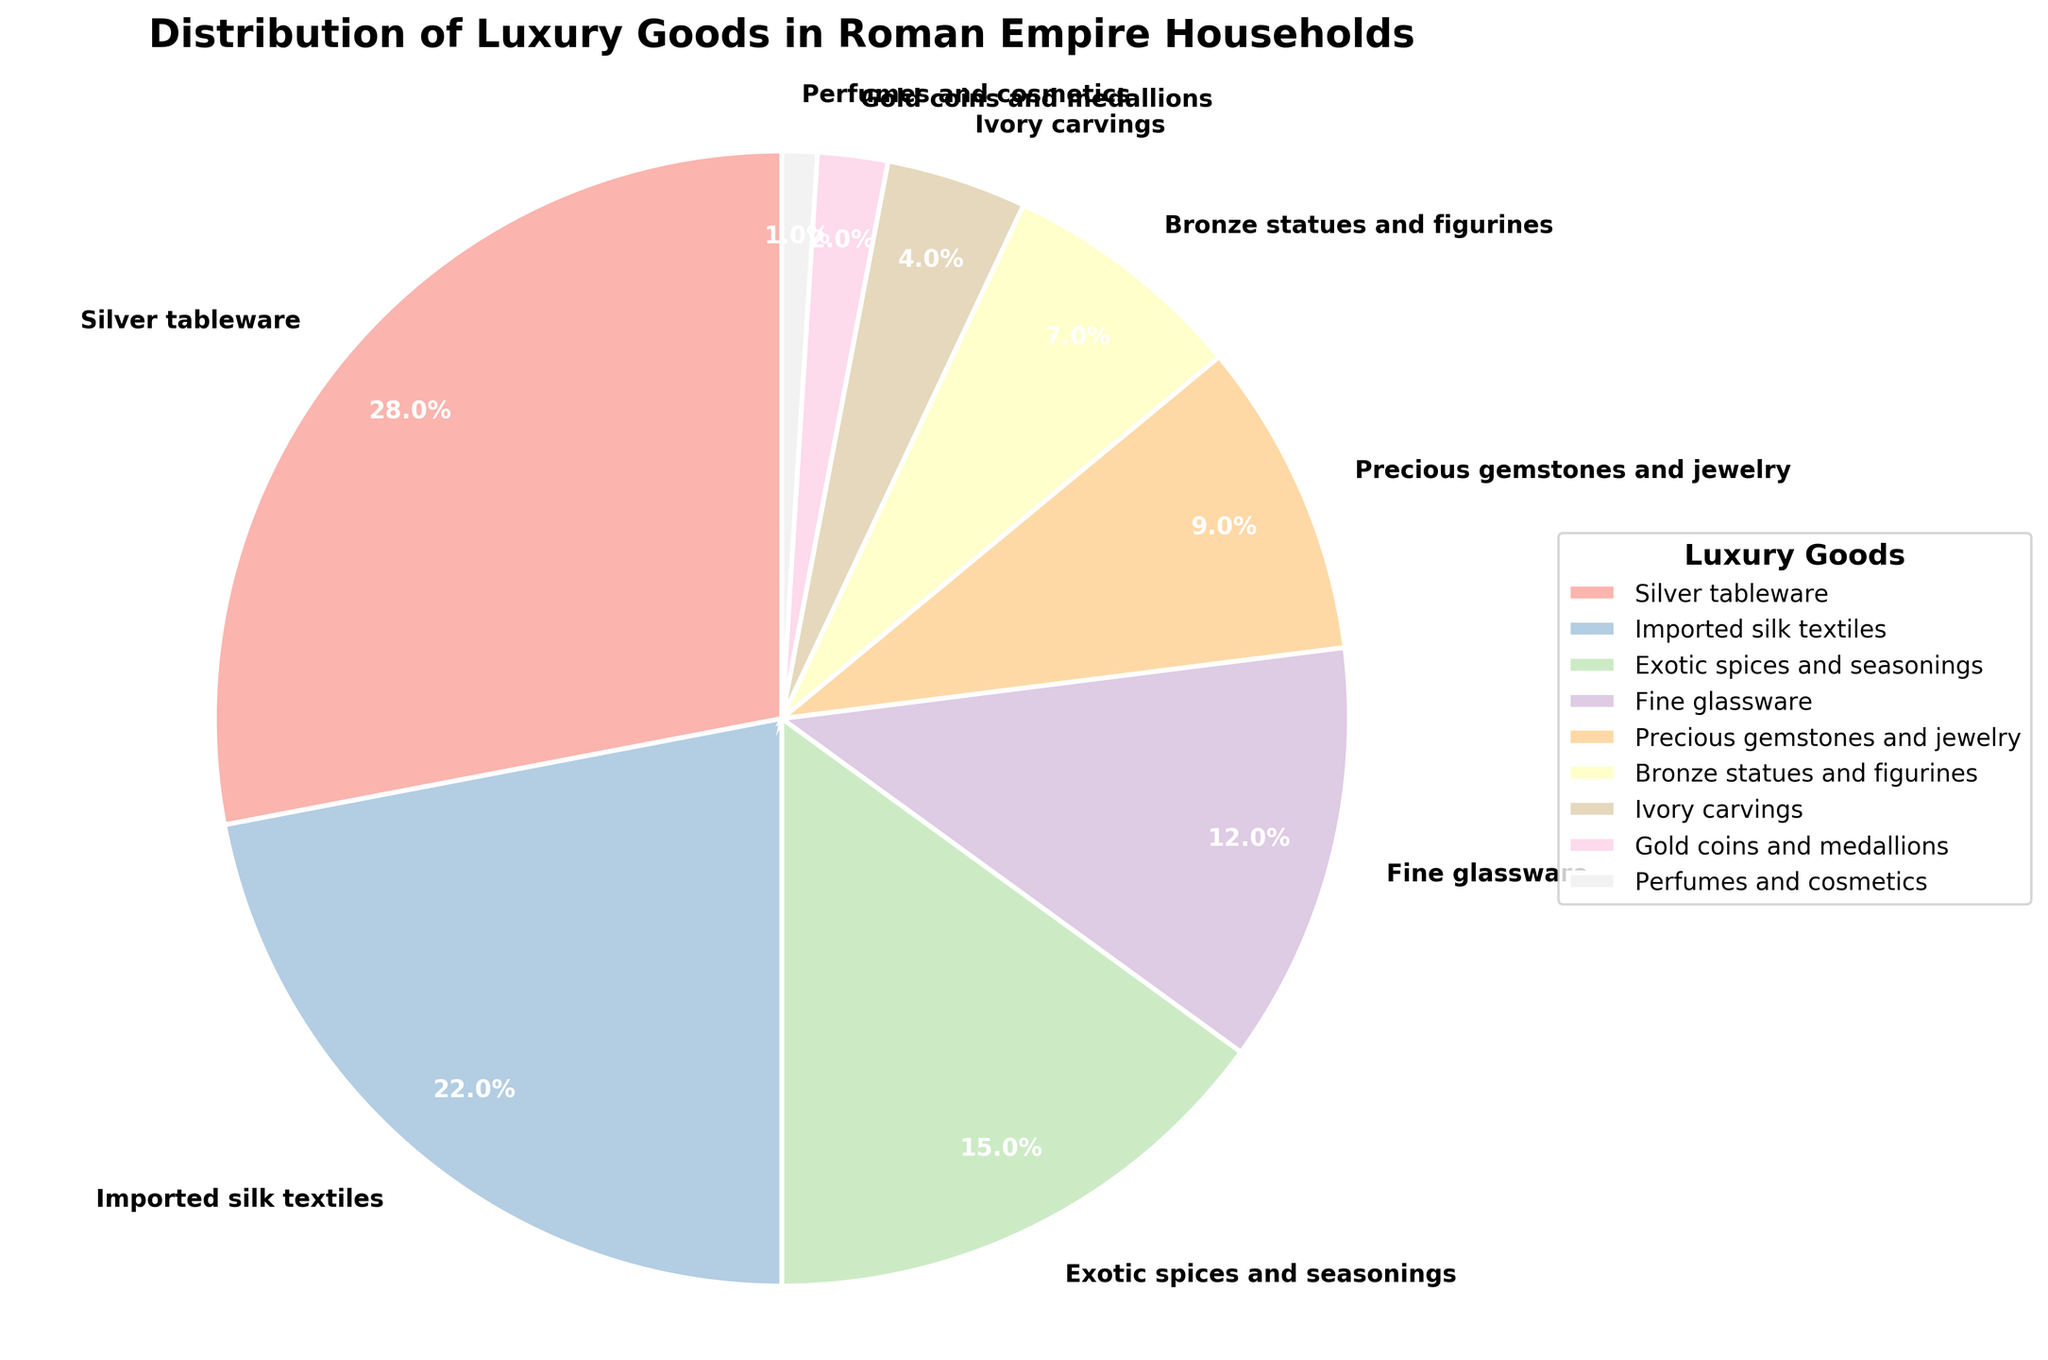Which category accounts for the largest percentage of luxury goods? The largest wedge on the pie chart is 'Silver tableware'. By observing the distribution, 'Silver tableware' occupies the greatest area, indicating its dominance.
Answer: Silver tableware Which two categories make up exactly half of the household distribution of luxury goods together? Adding the percentages of 'Silver tableware' (28%) and 'Imported silk textiles' (22%), it gives a total of 50%: 28 + 22 = 50.
Answer: Silver tableware and Imported silk textiles How much larger is the percentage of Exotic spices and seasonings compared to Bronze statues and figurines? The percentage for 'Exotic spices and seasonings' is 15%, and 'Bronze statues and figurines' is 7%. The difference is calculated as 15 - 7 = 8.
Answer: 8% Are there any categories that make up less than 5% each of the distribution? If yes, list them. By observing the pie chart, 'Ivory carvings' (4%), 'Gold coins and medallions' (2%), and 'Perfumes and cosmetics' (1%) are each less than 5% of the distribution.
Answer: Ivory carvings, Gold coins and medallions, Perfumes and cosmetics What is the combined percentage of Fine glassware and Precious gemstones and jewelry? Adding 'Fine glassware' (12%) and 'Precious gemstones and jewelry' (9%), the combined percentage is: 12 + 9 = 21.
Answer: 21% Which luxury good has the smallest share in the distribution? The smallest wedge on the pie chart is 'Perfumes and cosmetics', indicating it has the smallest share, 1%.
Answer: Perfumes and cosmetics How do Gold coins and medallions compare to Imported silk textiles in terms of distribution share? 'Gold coins and medallions' account for 2%, while 'Imported silk textiles' account for 22%. The share of 'Imported silk textiles' is much larger.
Answer: Imported silk textiles have a much larger share What's the difference between the share of Precious gemstones and jewelry and Fine glassware? 'Precious gemstones and jewelry' have a share of 9%, while 'Fine glassware' has a share of 12%. The difference is calculated as 12 - 9 = 3.
Answer: 3% If we combined Bronze statues and figurines with Exotic spices and seasonings, how would their combined percentage compare to Silver tableware? The combined percentage of 'Bronze statues and figurines' (7%) and 'Exotic spices and seasonings' (15%) is: 7 + 15 = 22%. 'Silver tableware' accounts for 28%, so 22% is less than 28%.
Answer: Less than Silver tableware 